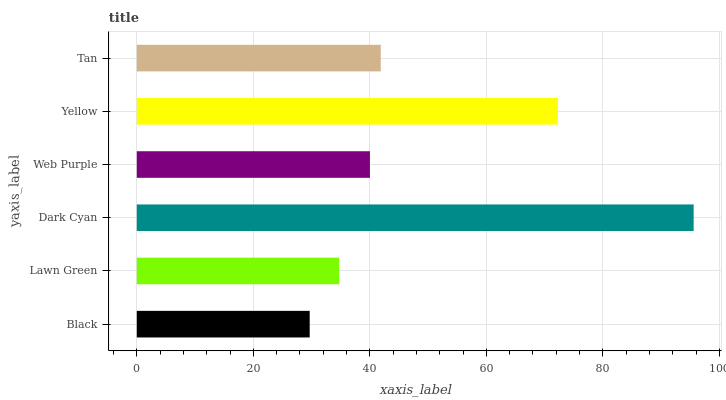Is Black the minimum?
Answer yes or no. Yes. Is Dark Cyan the maximum?
Answer yes or no. Yes. Is Lawn Green the minimum?
Answer yes or no. No. Is Lawn Green the maximum?
Answer yes or no. No. Is Lawn Green greater than Black?
Answer yes or no. Yes. Is Black less than Lawn Green?
Answer yes or no. Yes. Is Black greater than Lawn Green?
Answer yes or no. No. Is Lawn Green less than Black?
Answer yes or no. No. Is Tan the high median?
Answer yes or no. Yes. Is Web Purple the low median?
Answer yes or no. Yes. Is Yellow the high median?
Answer yes or no. No. Is Dark Cyan the low median?
Answer yes or no. No. 